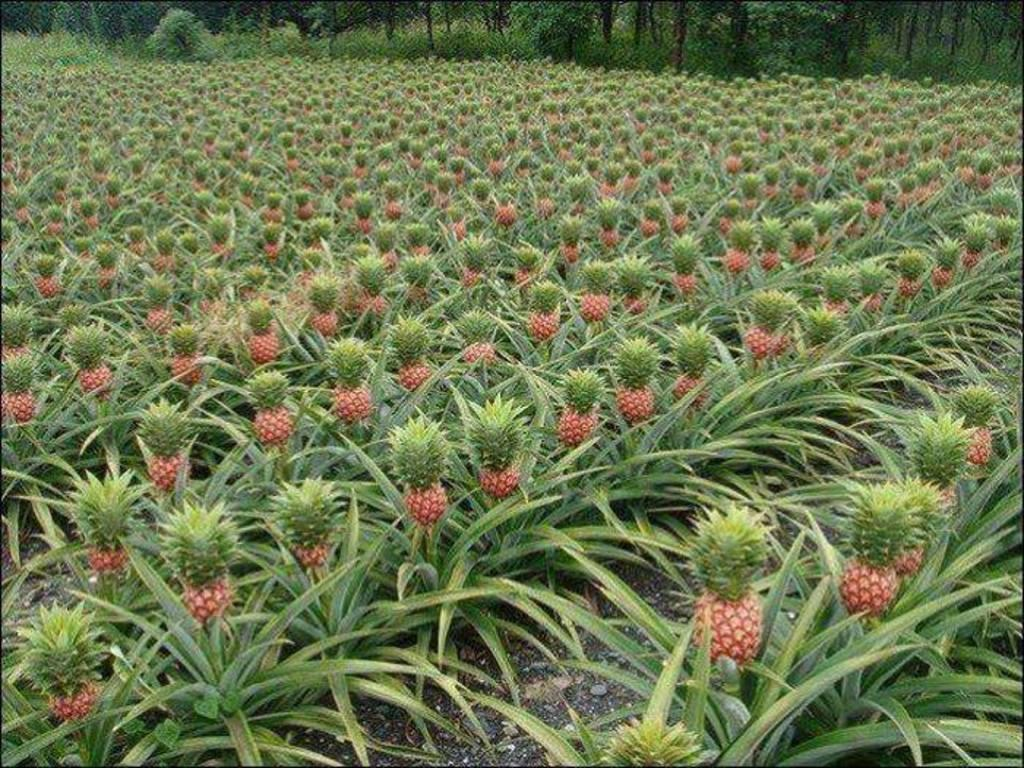What type of plants can be seen in the image? There are plants with pineapples in the image. What can be seen in the background of the image? There are trees in the background of the image. What invention is being exchanged between the plants in the image? There is no invention being exchanged between the plants in the image; it simply shows plants with pineapples. 